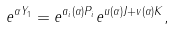Convert formula to latex. <formula><loc_0><loc_0><loc_500><loc_500>e ^ { \alpha Y _ { 1 } } = e ^ { a _ { i } ( \alpha ) P _ { i } } e ^ { u ( \alpha ) J + v ( \alpha ) K } ,</formula> 